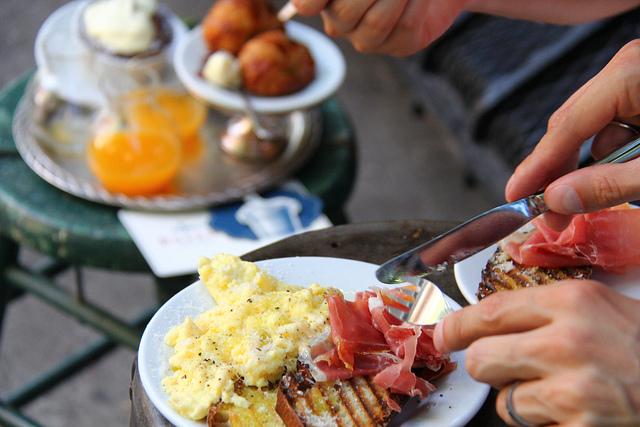How many fried eggs can be seen?
Answer briefly. 0. Does this ham look fresh?
Be succinct. Yes. Is there orange juice in this picture?
Write a very short answer. Yes. 